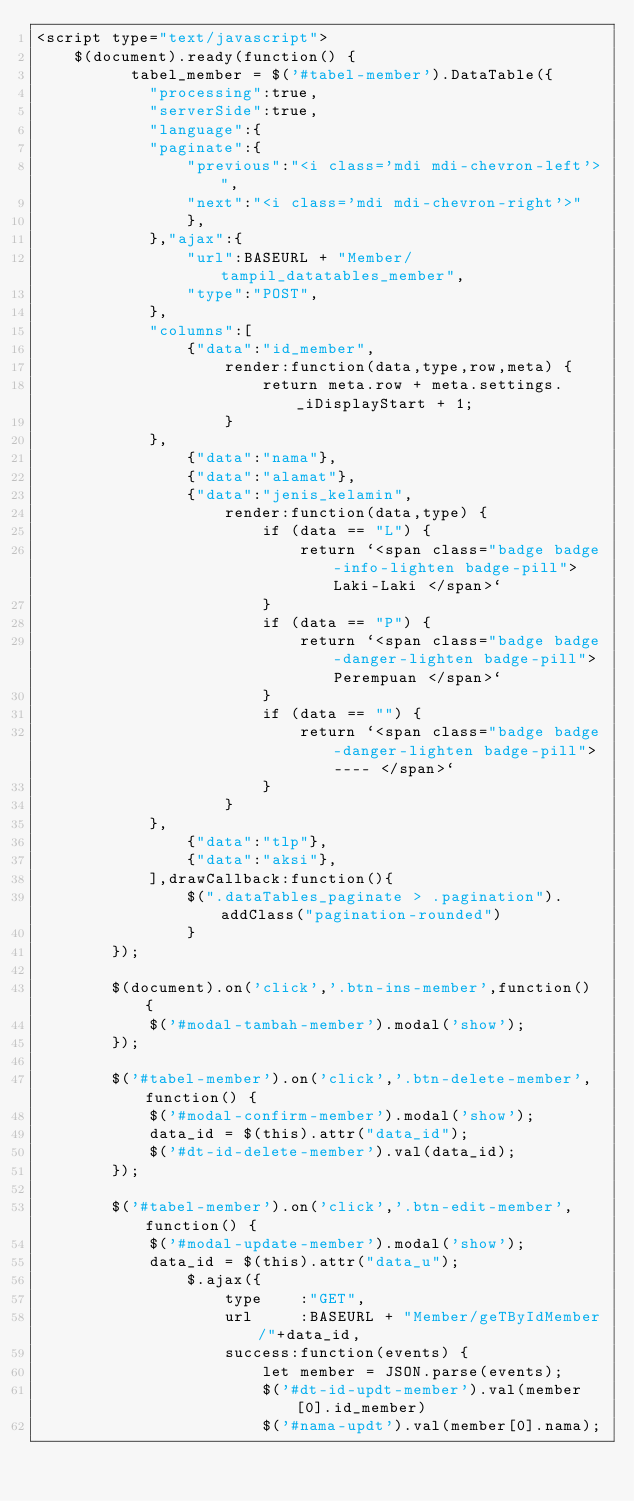Convert code to text. <code><loc_0><loc_0><loc_500><loc_500><_PHP_><script type="text/javascript">
	$(document).ready(function() {
		  tabel_member = $('#tabel-member').DataTable({
			"processing":true,
			"serverSide":true,
			"language":{
			"paginate":{
				"previous":"<i class='mdi mdi-chevron-left'>",
				"next":"<i class='mdi mdi-chevron-right'>"
				},
			},"ajax":{
				"url":BASEURL + "Member/tampil_datatables_member",
				"type":"POST",
			},
			"columns":[
				{"data":"id_member",
					render:function(data,type,row,meta) {
						return meta.row + meta.settings._iDisplayStart + 1;
					}
			},
				{"data":"nama"},
				{"data":"alamat"},
				{"data":"jenis_kelamin",
					render:function(data,type) {
						if (data == "L") {
							return `<span class="badge badge-info-lighten badge-pill"> Laki-Laki </span>`
						}
						if (data == "P") {
							return `<span class="badge badge-danger-lighten badge-pill"> Perempuan </span>`
						}
						if (data == "") {
							return `<span class="badge badge-danger-lighten badge-pill"> ---- </span>`
						}
					}
			},
				{"data":"tlp"},
				{"data":"aksi"},
			],drawCallback:function(){
				$(".dataTables_paginate > .pagination").addClass("pagination-rounded")
				}
		}); 

		$(document).on('click','.btn-ins-member',function() {
			$('#modal-tambah-member').modal('show');
		});

		$('#tabel-member').on('click','.btn-delete-member',function() {
			$('#modal-confirm-member').modal('show');
			data_id = $(this).attr("data_id");
			$('#dt-id-delete-member').val(data_id);
		});

		$('#tabel-member').on('click','.btn-edit-member',function() {
			$('#modal-update-member').modal('show');
			data_id = $(this).attr("data_u");
				$.ajax({
					type 	:"GET",
					url 	:BASEURL + "Member/geTByIdMember/"+data_id,
					success:function(events) {
						let member = JSON.parse(events);
						$('#dt-id-updt-member').val(member[0].id_member)
						$('#nama-updt').val(member[0].nama);</code> 